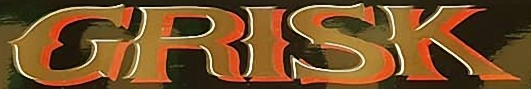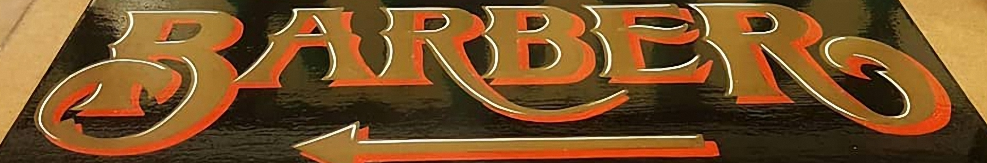Read the text content from these images in order, separated by a semicolon. GRISK; BARBER 